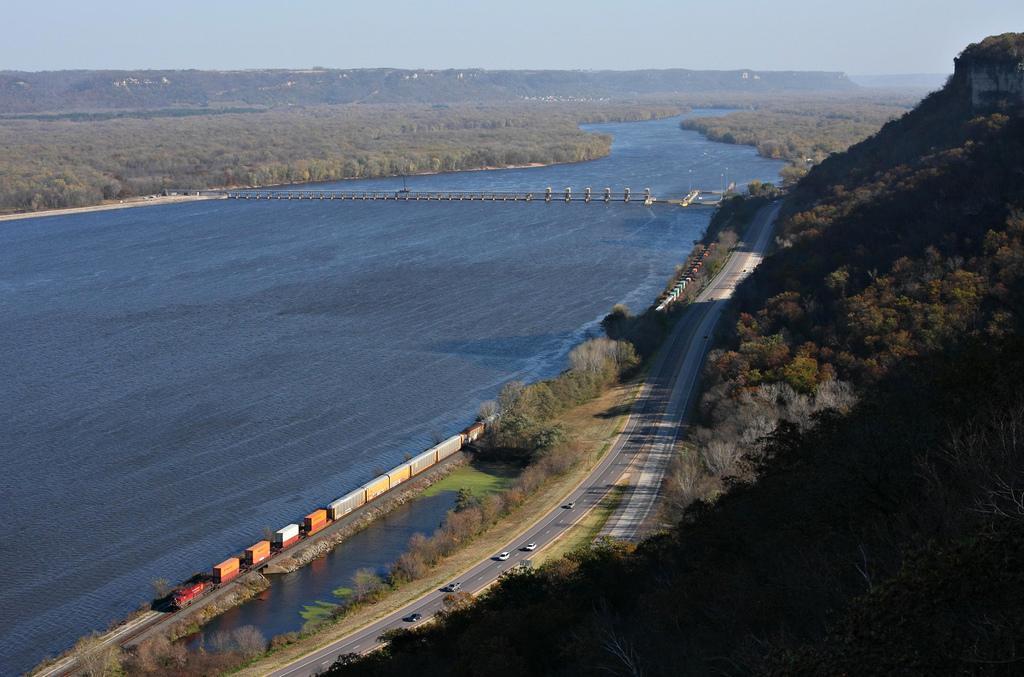Please provide a concise description of this image. In the image we can see the road, vehicles on the road, train, grass, trees, water, mountain and a sky. 